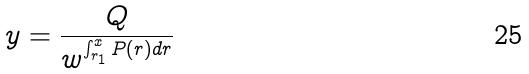<formula> <loc_0><loc_0><loc_500><loc_500>y = \frac { Q } { w ^ { \int _ { r _ { 1 } } ^ { x } P ( r ) d r } }</formula> 